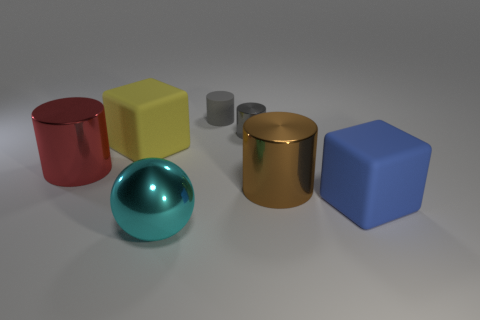Add 2 small brown blocks. How many objects exist? 9 Subtract all blocks. How many objects are left? 5 Add 5 shiny objects. How many shiny objects exist? 9 Subtract 0 cyan cylinders. How many objects are left? 7 Subtract all yellow blocks. Subtract all big red metal things. How many objects are left? 5 Add 5 big red metal cylinders. How many big red metal cylinders are left? 6 